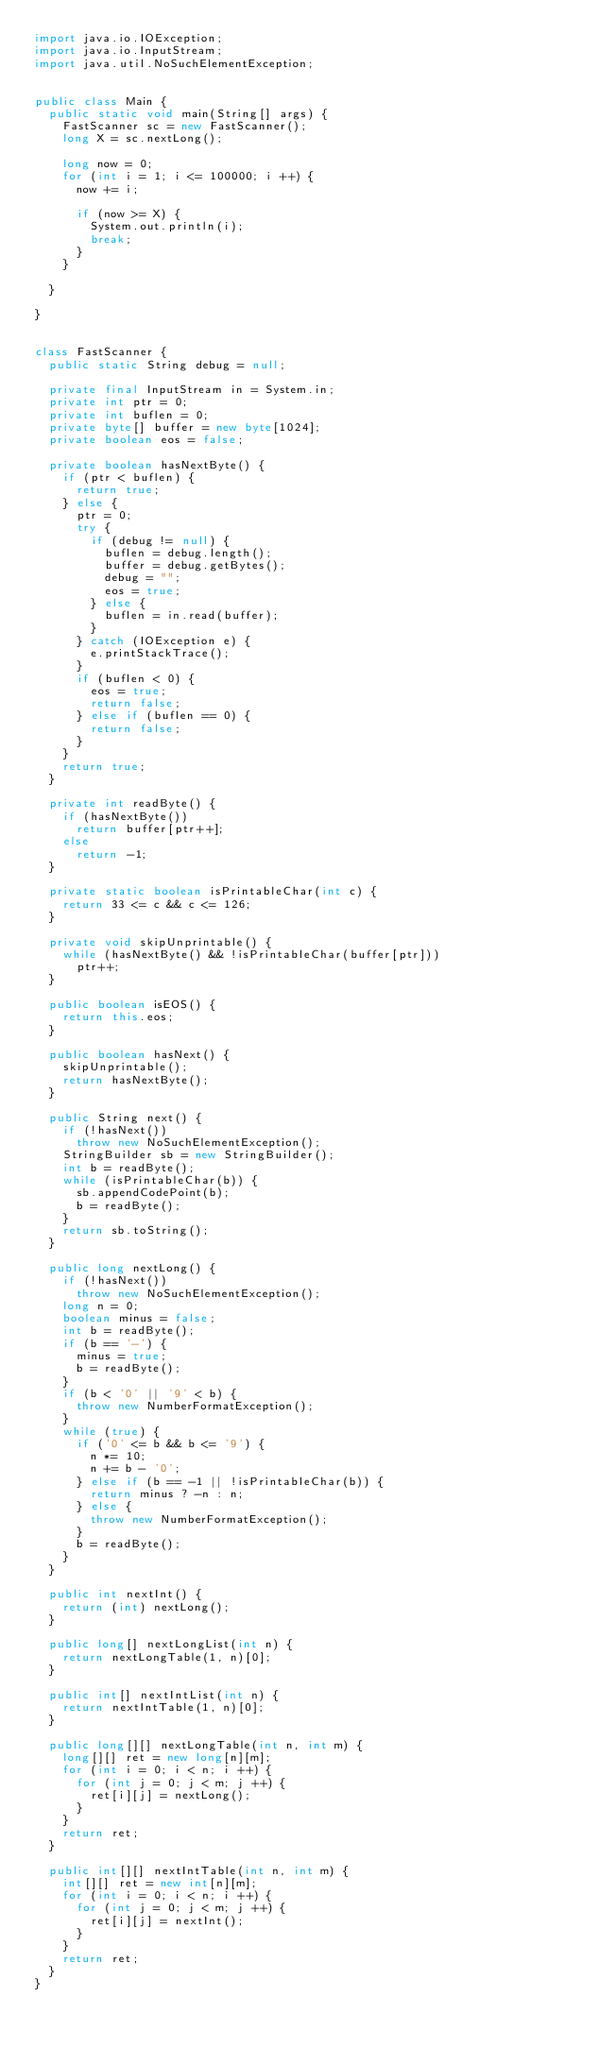Convert code to text. <code><loc_0><loc_0><loc_500><loc_500><_Java_>import java.io.IOException;
import java.io.InputStream;
import java.util.NoSuchElementException;


public class Main {
  public static void main(String[] args) {
    FastScanner sc = new FastScanner();
    long X = sc.nextLong();
    
    long now = 0;
    for (int i = 1; i <= 100000; i ++) {
      now += i;
      
      if (now >= X) {
        System.out.println(i);
        break;
      }
    }
    
  }

}


class FastScanner {
	public static String debug = null;

	private final InputStream in = System.in;
	private int ptr = 0;
	private int buflen = 0;
	private byte[] buffer = new byte[1024];
	private boolean eos = false;

	private boolean hasNextByte() {
		if (ptr < buflen) {
			return true;
		} else {
			ptr = 0;
			try {
				if (debug != null) {
					buflen = debug.length();
					buffer = debug.getBytes();
					debug = "";
					eos = true;
				} else {
					buflen = in.read(buffer);
				}
			} catch (IOException e) {
				e.printStackTrace();
			}
			if (buflen < 0) {
				eos = true;
				return false;
			} else if (buflen == 0) {
				return false;
			}
		}
		return true;
	}

	private int readByte() {
		if (hasNextByte())
			return buffer[ptr++];
		else
			return -1;
	}

	private static boolean isPrintableChar(int c) {
		return 33 <= c && c <= 126;
	}

	private void skipUnprintable() {
		while (hasNextByte() && !isPrintableChar(buffer[ptr]))
			ptr++;
	}

	public boolean isEOS() {
		return this.eos;
	}

	public boolean hasNext() {
		skipUnprintable();
		return hasNextByte();
	}

	public String next() {
		if (!hasNext())
			throw new NoSuchElementException();
		StringBuilder sb = new StringBuilder();
		int b = readByte();
		while (isPrintableChar(b)) {
			sb.appendCodePoint(b);
			b = readByte();
		}
		return sb.toString();
	}

	public long nextLong() {
		if (!hasNext())
			throw new NoSuchElementException();
		long n = 0;
		boolean minus = false;
		int b = readByte();
		if (b == '-') {
			minus = true;
			b = readByte();
		}
		if (b < '0' || '9' < b) {
			throw new NumberFormatException();
		}
		while (true) {
			if ('0' <= b && b <= '9') {
				n *= 10;
				n += b - '0';
			} else if (b == -1 || !isPrintableChar(b)) {
				return minus ? -n : n;
			} else {
				throw new NumberFormatException();
			}
			b = readByte();
		}
	}

	public int nextInt() {
		return (int) nextLong();
	}

	public long[] nextLongList(int n) {
		return nextLongTable(1, n)[0];
	}

	public int[] nextIntList(int n) {
		return nextIntTable(1, n)[0];
	}

	public long[][] nextLongTable(int n, int m) {
		long[][] ret = new long[n][m];
		for (int i = 0; i < n; i ++) {
			for (int j = 0; j < m; j ++) {
				ret[i][j] = nextLong();
			}
		}
		return ret;
	}

	public int[][] nextIntTable(int n, int m) {
		int[][] ret = new int[n][m];
		for (int i = 0; i < n; i ++) {
			for (int j = 0; j < m; j ++) {
				ret[i][j] = nextInt();
			}
		}
		return ret;
	}
}</code> 